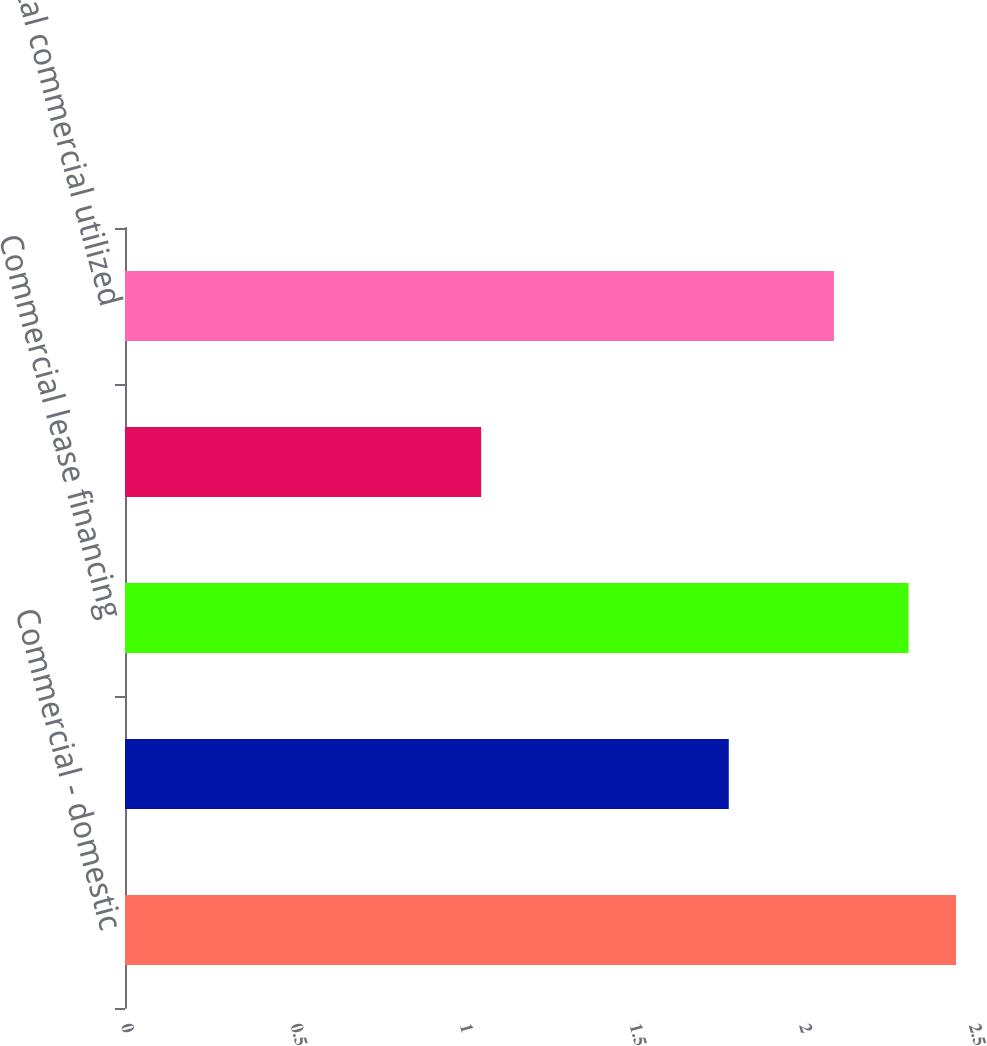Convert chart. <chart><loc_0><loc_0><loc_500><loc_500><bar_chart><fcel>Commercial - domestic<fcel>Commercial real estate<fcel>Commercial lease financing<fcel>Commercial - foreign<fcel>Total commercial utilized<nl><fcel>2.45<fcel>1.78<fcel>2.31<fcel>1.05<fcel>2.09<nl></chart> 